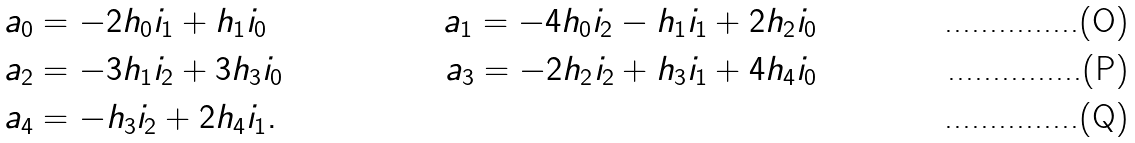<formula> <loc_0><loc_0><loc_500><loc_500>a _ { 0 } & = - 2 h _ { 0 } i _ { 1 } + h _ { 1 } i _ { 0 } \quad & a _ { 1 } = - 4 h _ { 0 } i _ { 2 } - h _ { 1 } i _ { 1 } + 2 h _ { 2 } i _ { 0 } \\ a _ { 2 } & = - 3 h _ { 1 } i _ { 2 } + 3 h _ { 3 } i _ { 0 } \quad & a _ { 3 } = - 2 h _ { 2 } i _ { 2 } + h _ { 3 } i _ { 1 } + 4 h _ { 4 } i _ { 0 } \\ a _ { 4 } & = - h _ { 3 } i _ { 2 } + 2 h _ { 4 } i _ { 1 } .</formula> 